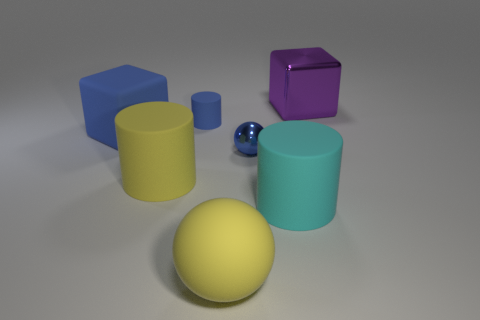What is the size of the blue cube that is the same material as the blue cylinder?
Provide a succinct answer. Large. Does the cube that is right of the blue rubber block have the same material as the big cylinder right of the big yellow matte ball?
Ensure brevity in your answer.  No. How many blocks are either small green rubber things or rubber things?
Keep it short and to the point. 1. There is a large cylinder that is in front of the big yellow cylinder that is in front of the large shiny object; what number of big yellow cylinders are to the right of it?
Provide a short and direct response. 0. What material is the other big thing that is the same shape as the large metal object?
Your answer should be compact. Rubber. There is a cube in front of the shiny block; what is its color?
Keep it short and to the point. Blue. Is the purple cube made of the same material as the large yellow object on the right side of the blue matte cylinder?
Keep it short and to the point. No. What is the cyan cylinder made of?
Ensure brevity in your answer.  Rubber. There is a small blue thing that is made of the same material as the cyan object; what is its shape?
Your answer should be compact. Cylinder. How many other objects are the same shape as the blue shiny object?
Provide a short and direct response. 1. 